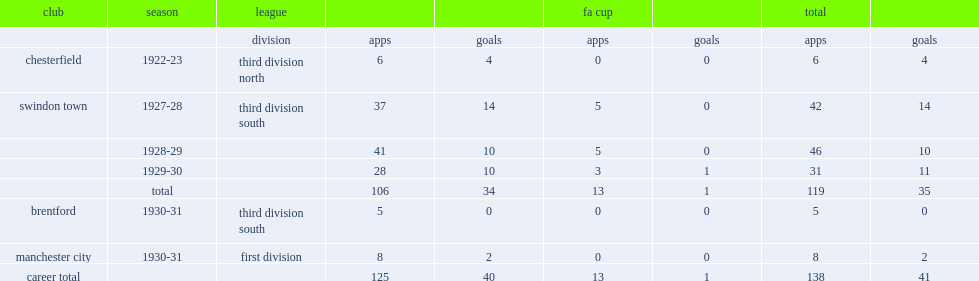Write the full table. {'header': ['club', 'season', 'league', '', '', 'fa cup', '', 'total', ''], 'rows': [['', '', 'division', 'apps', 'goals', 'apps', 'goals', 'apps', 'goals'], ['chesterfield', '1922-23', 'third division north', '6', '4', '0', '0', '6', '4'], ['swindon town', '1927-28', 'third division south', '37', '14', '5', '0', '42', '14'], ['', '1928-29', '', '41', '10', '5', '0', '46', '10'], ['', '1929-30', '', '28', '10', '3', '1', '31', '11'], ['', 'total', '', '106', '34', '13', '1', '119', '35'], ['brentford', '1930-31', 'third division south', '5', '0', '0', '0', '5', '0'], ['manchester city', '1930-31', 'first division', '8', '2', '0', '0', '8', '2'], ['career total', '', '', '125', '40', '13', '1', '138', '41']]} How many goals did les roberts play for swindon town totally? 35.0. 